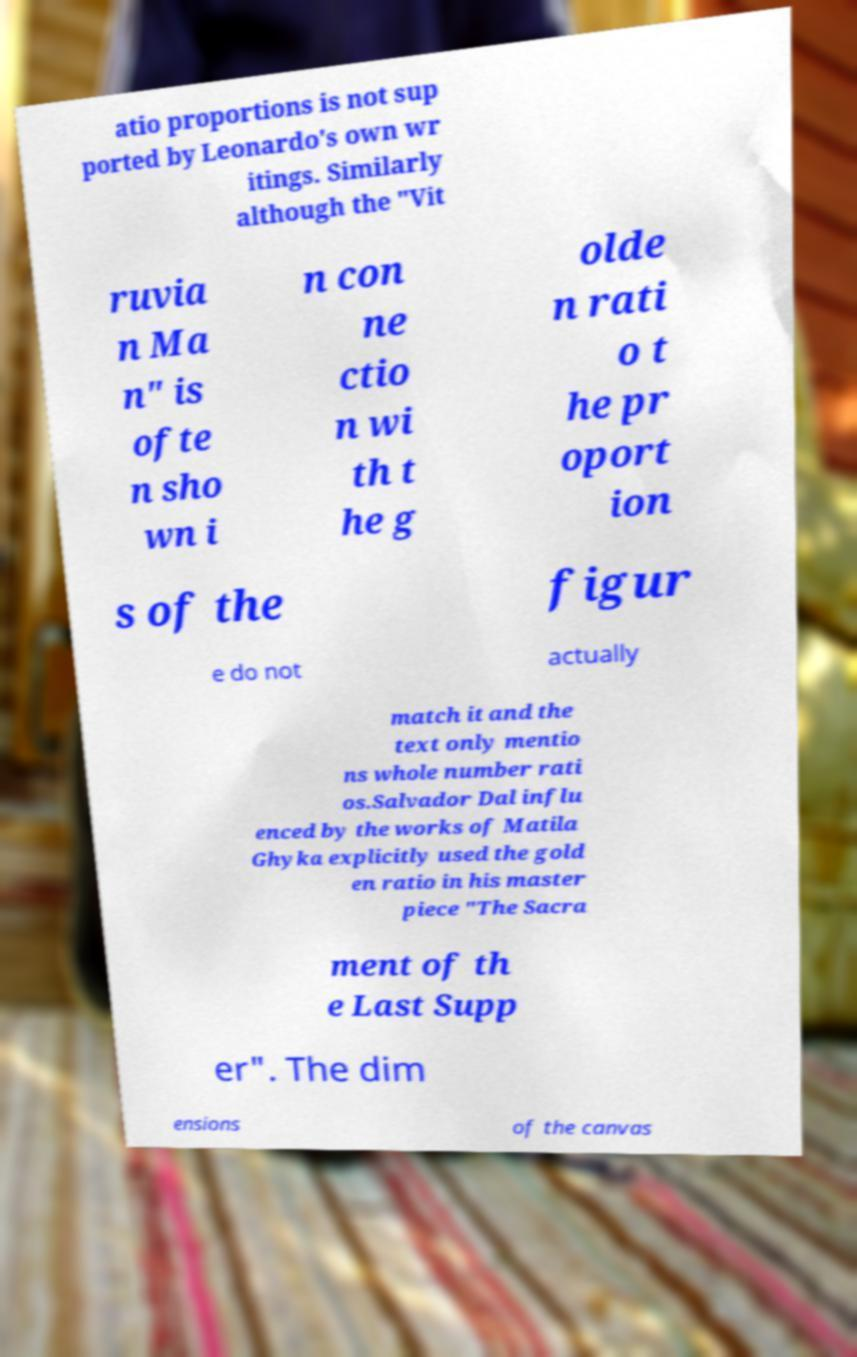Could you assist in decoding the text presented in this image and type it out clearly? atio proportions is not sup ported by Leonardo's own wr itings. Similarly although the "Vit ruvia n Ma n" is ofte n sho wn i n con ne ctio n wi th t he g olde n rati o t he pr oport ion s of the figur e do not actually match it and the text only mentio ns whole number rati os.Salvador Dal influ enced by the works of Matila Ghyka explicitly used the gold en ratio in his master piece "The Sacra ment of th e Last Supp er". The dim ensions of the canvas 